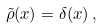Convert formula to latex. <formula><loc_0><loc_0><loc_500><loc_500>\tilde { \rho } ( x ) = \delta ( x ) \, ,</formula> 